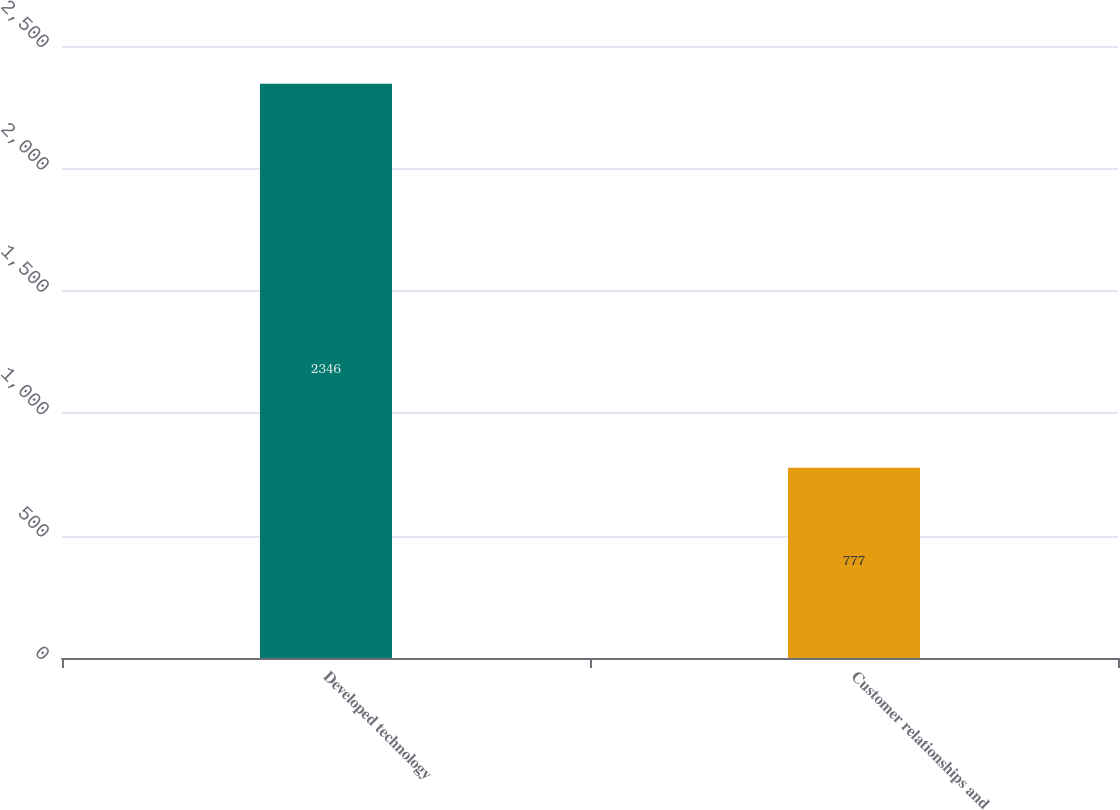Convert chart. <chart><loc_0><loc_0><loc_500><loc_500><bar_chart><fcel>Developed technology<fcel>Customer relationships and<nl><fcel>2346<fcel>777<nl></chart> 